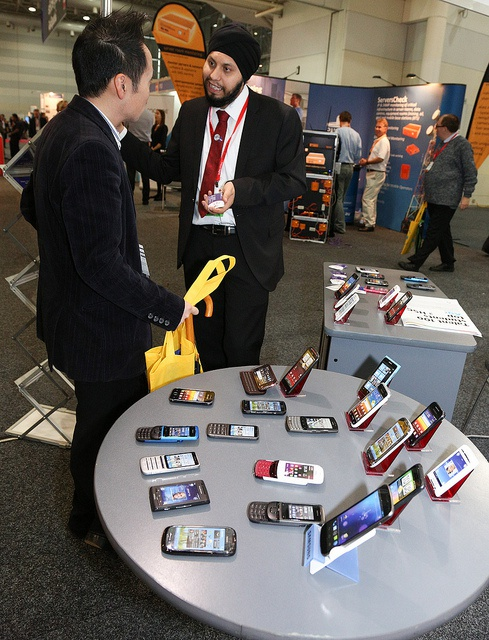Describe the objects in this image and their specific colors. I can see dining table in black, darkgray, lightgray, and gray tones, people in black, tan, and gray tones, people in black, lightgray, maroon, and gray tones, cell phone in black, white, gray, and darkgray tones, and people in black, gray, and maroon tones in this image. 